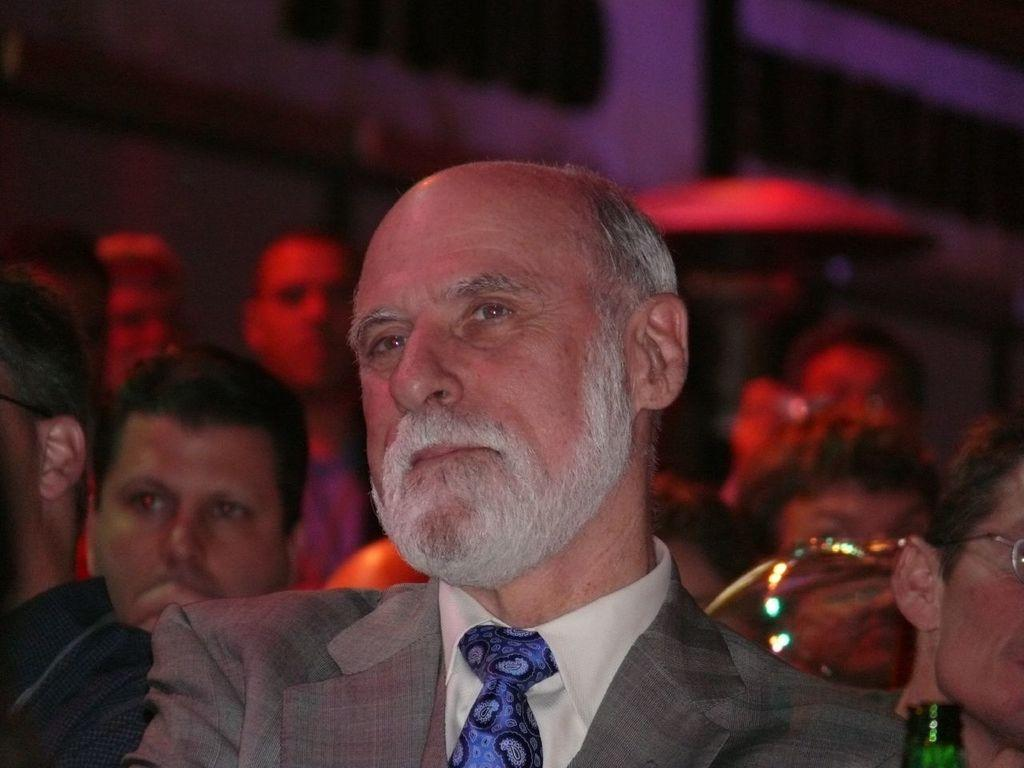How many people are in the image? There is a group of people in the image, but the exact number is not specified. What are the people in the image doing? The people are sitting in the image. What can be seen in the background of the image? There is a building in the background of the image. What else is visible in the image besides the people and the building? There is some text visible in the image. What type of sock is the dinosaur wearing in the image? There is no dinosaur or sock present in the image. What error can be seen in the text visible in the image? There is no mention of an error in the text visible in the image. 